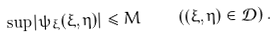Convert formula to latex. <formula><loc_0><loc_0><loc_500><loc_500>\sup | \psi _ { \xi } ( \xi , \eta ) | \leq M \quad \left ( ( \xi , \eta ) \in { \mathcal { D } } \right ) .</formula> 